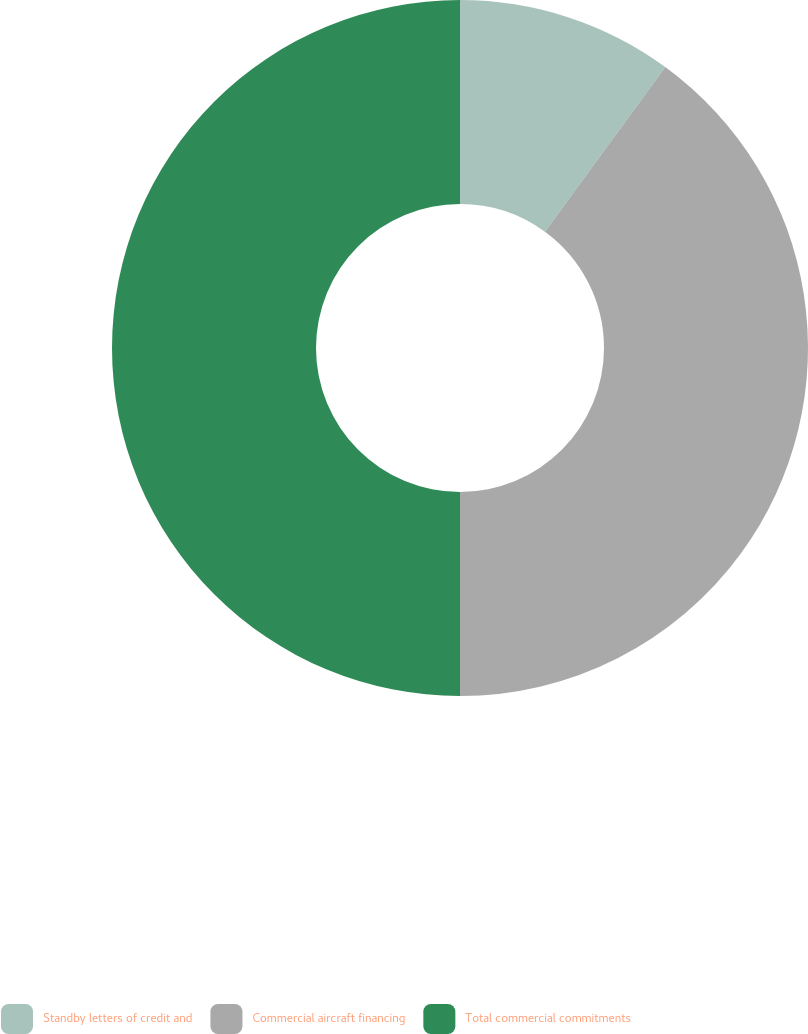Convert chart to OTSL. <chart><loc_0><loc_0><loc_500><loc_500><pie_chart><fcel>Standby letters of credit and<fcel>Commercial aircraft financing<fcel>Total commercial commitments<nl><fcel>10.04%<fcel>39.96%<fcel>50.0%<nl></chart> 